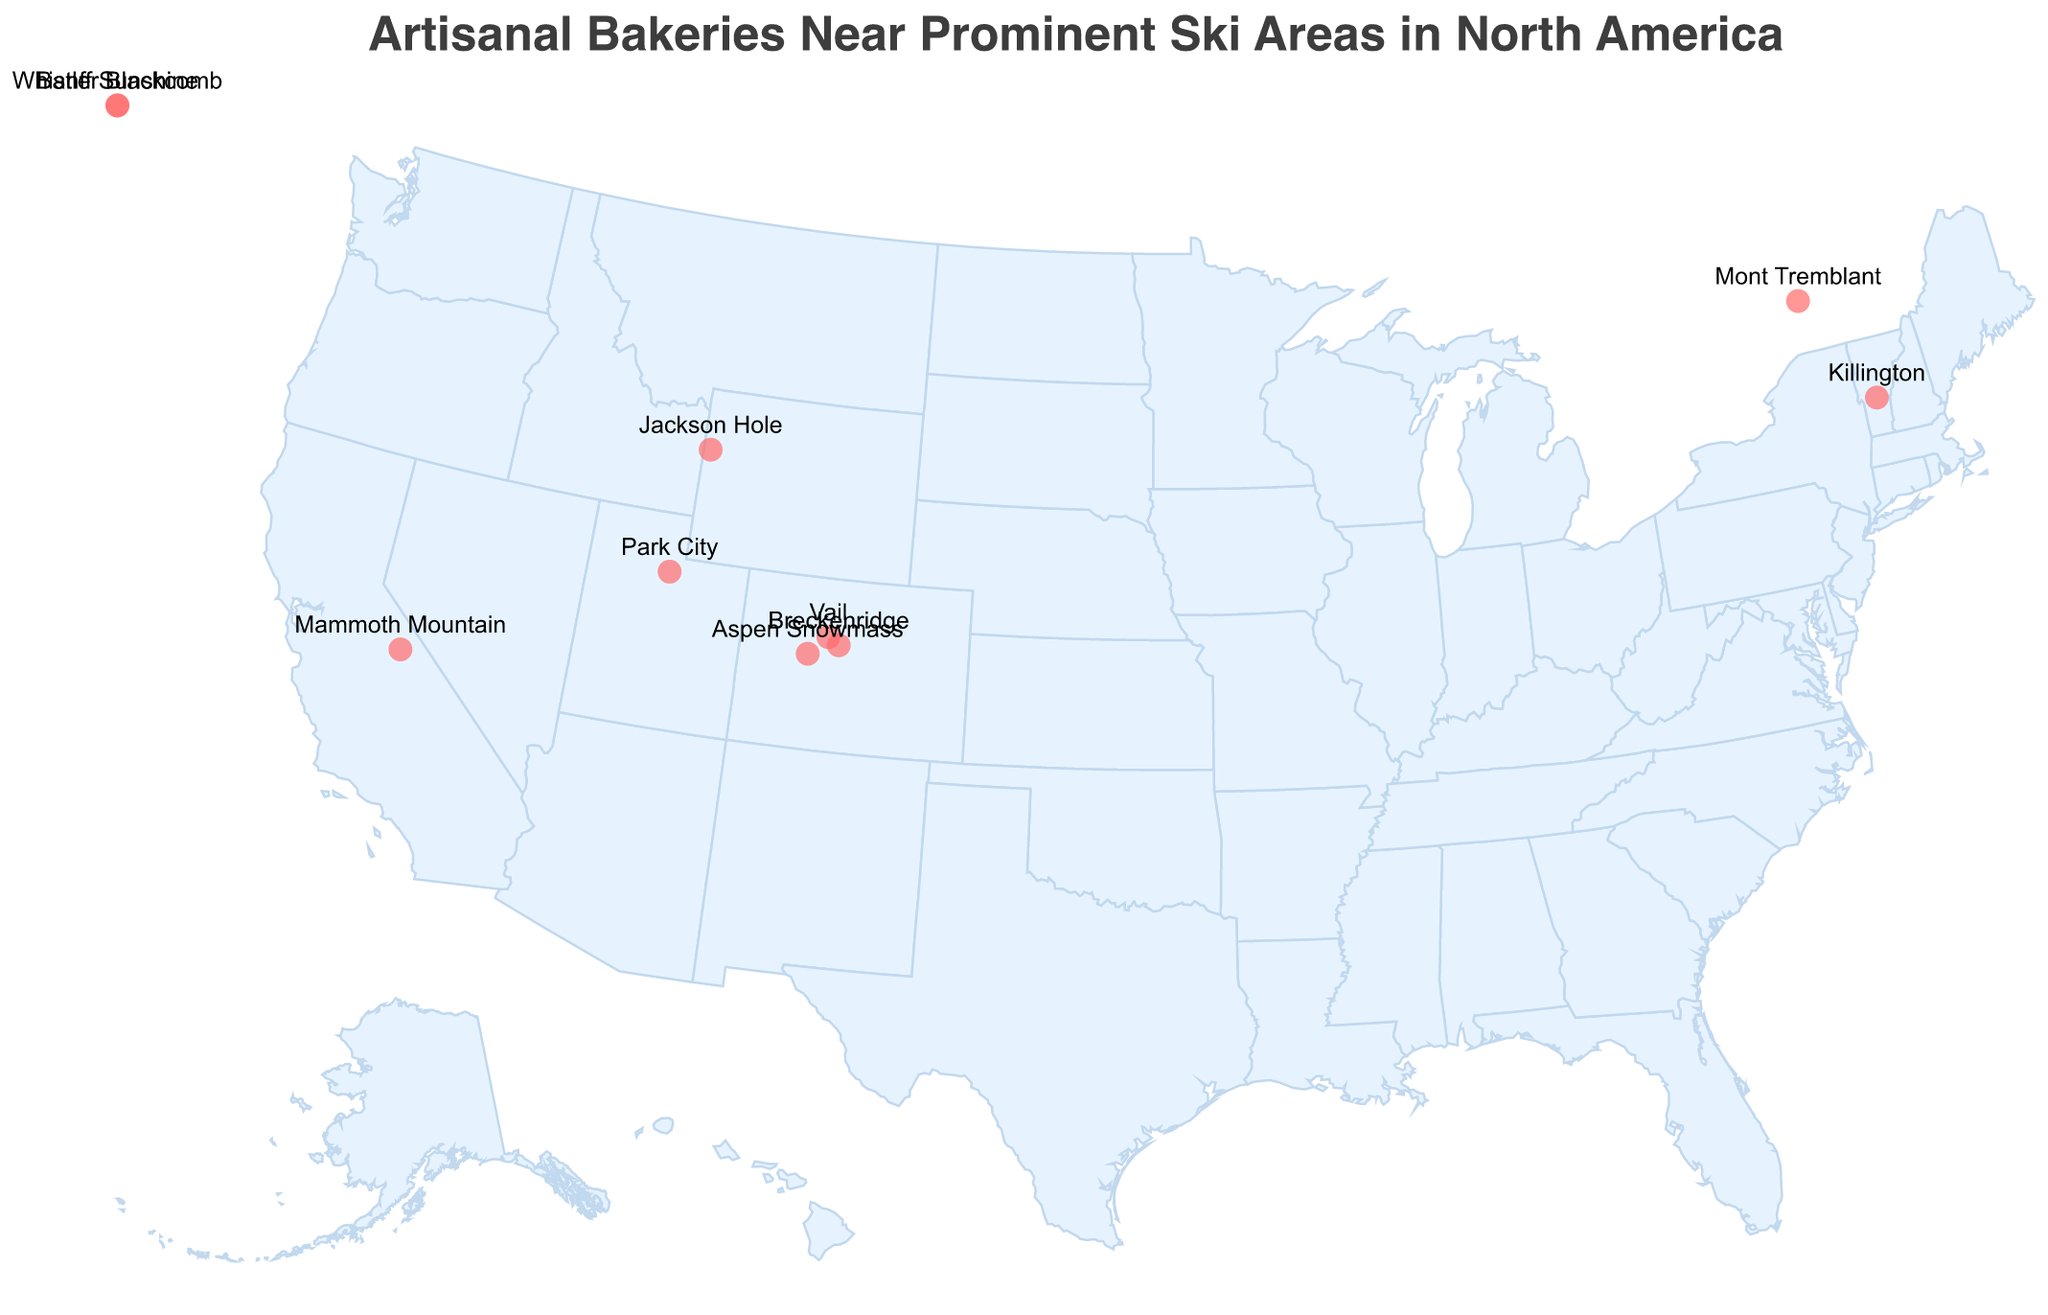What is the title of the plot? The title is the text that appears prominently at the top of the plot. It summarizes what the figure shows. In this case, the title reads "Artisanal Bakeries Near Prominent Ski Areas in North America".
Answer: Artisanal Bakeries Near Prominent Ski Areas in North America How many ski resorts are represented on the map? The visual data points on the map represent the number of ski resorts. Each circle corresponds to a ski resort. Counting these, we find there are ten in total.
Answer: 10 Which bakery is closest to Whistler Blackcomb? Checking the tooltip or labels, "Whistler Blackcomb" has the bakery "Alpine Delights". Each data point has an associated bakery name visible on the tooltip near Whistler Blackcomb's location.
Answer: Alpine Delights What's the specialty pastry of the bakery near Killington? By examining the label or tooltip data near the geographic location of Killington, it's associated with the "Vermont Sugar Shack" bakery, which specializes in "Blueberry Cheesecake Danishes".
Answer: Blueberry Cheesecake Danishes Which ski resort is closest to 40° latitude, -111° longitude? Observing the location on the map, the point closest to this latitude and longitude is Park City. The tooltip reveals this location.
Answer: Park City Which bakery is located at the highest latitude? By checking the latitude values, the highest latitude is 51.1154. The corresponding tooltip indicates this is "Rocky Mountain Rise" near Banff Sunshine.
Answer: Rocky Mountain Rise What are the two bakeries located in Colorado, and what are their specialties? There are two points in the plot in Colorado. Hovering over these provides tooltips indicating "Powder Peak Pastries" in Vail specializes in "Chocolate Chunk Ski Boot Cookies", and "Frosted Peaks Bakery" in Breckenridge specializes in "Peanut Butter S'mores Bars".
Answer: Powder Peak Pastries: Chocolate Chunk Ski Boot Cookies, Frosted Peaks Bakery: Peanut Butter S'mores Bars Which specialty pastry can be found in a bakery near Mammoth Mountain? Hovering over Mammoth Mountain reveals the corresponding bakery "Sierra Sunrise Bakehouse" which specializes in "Huckleberry Streusel Muffins".
Answer: Huckleberry Streusel Muffins Is the bakery near Jackson Hole offering a savory pastry? Checking the tooltip for Jackson Hole reveals "Teton Treat Factory" with the specialty "Bison Bacon Savory Scones". The name indicates it is indeed a savory pastry.
Answer: Yes 